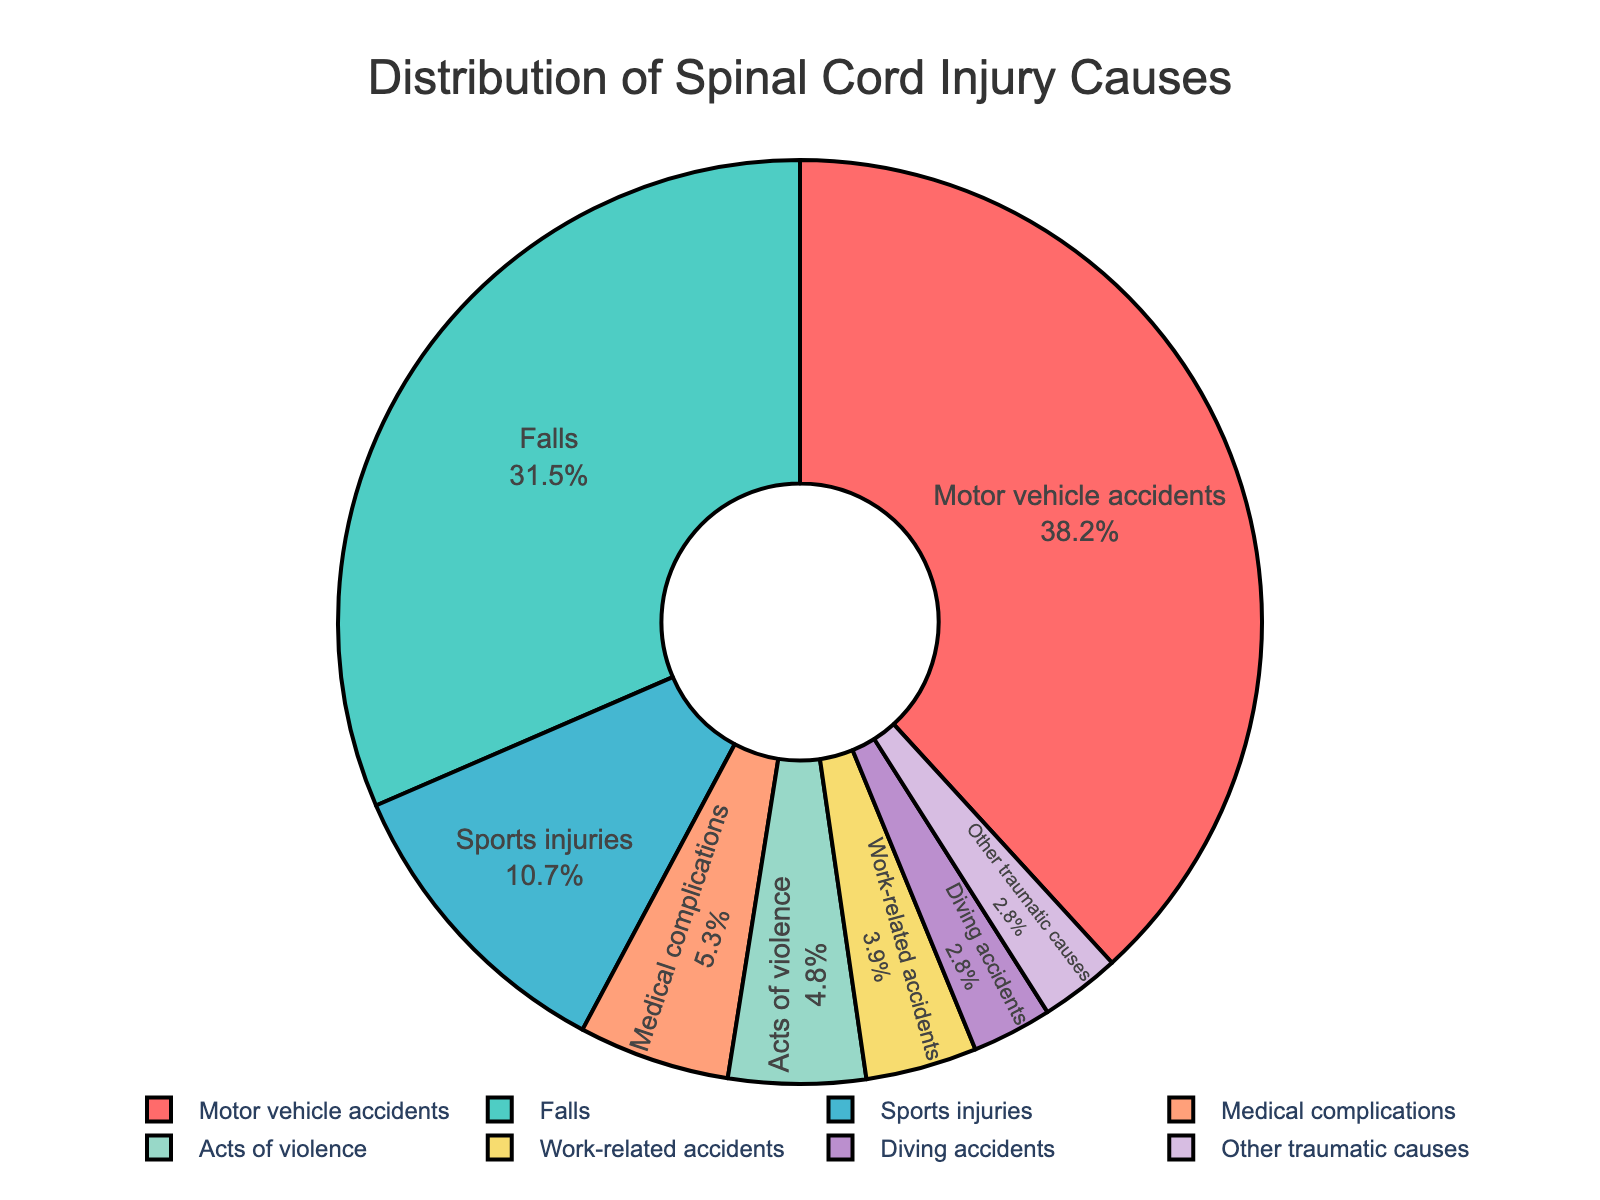What is the most common cause of spinal cord injury according to the figure? The largest segment in the pie chart represents motor vehicle accidents, with the highest percentage labeled as 38.2%.
Answer: Motor vehicle accidents What percentage of spinal cord injuries are caused by sports injuries and diving accidents combined? The percentage for sports injuries is 10.7% and for diving accidents is 2.8%. Adding these together, 10.7% + 2.8% = 13.5%.
Answer: 13.5% Which cause of spinal cord injury has a lower percentage: falls or acts of violence? The segment for falls is labeled as 31.5%, and the segment for acts of violence is labeled as 4.8%. Since 4.8% is less than 31.5%, acts of violence has a lower percentage.
Answer: Acts of violence What is the combined percentage of injuries caused by work-related accidents and diving accidents? The percentage for work-related accidents is 3.9% and for diving accidents is 2.8%. Adding these together, 3.9% + 2.8% = 6.7%.
Answer: 6.7% By how much does the percentage of motor vehicle accidents exceed the percentage of sports injuries? The percentage for motor vehicle accidents is 38.2% and for sports injuries is 10.7%. Subtracting these, 38.2% - 10.7% = 27.5%.
Answer: 27.5% What percentage of spinal cord injuries are due to causes other than motor vehicle accidents and falls? The total percentage for motor vehicle accidents is 38.2% and for falls is 31.5%. Adding these, 38.2% + 31.5% = 69.7%. Subtracting this from 100%, 100% - 69.7% = 30.3%.
Answer: 30.3% Which cause(s) of spinal cord injury have the same percentage according to the figure? Both diving accidents and other traumatic causes have a percentage of 2.8%.
Answer: Diving accidents and other traumatic causes How does the percentage of falls compare to medical complications? The segment for falls is labeled as 31.5%, while the medical complications segment is labeled as 5.3%. Since 31.5% is greater than 5.3%, falls are more common.
Answer: Falls What is the total percentage of spinal cord injuries caused by medical complications, acts of violence, and work-related accidents? The percentage for medical complications is 5.3%, acts of violence is 4.8%, and work-related accidents is 3.9%. Adding these together, 5.3% + 4.8% + 3.9% = 14%.
Answer: 14% 